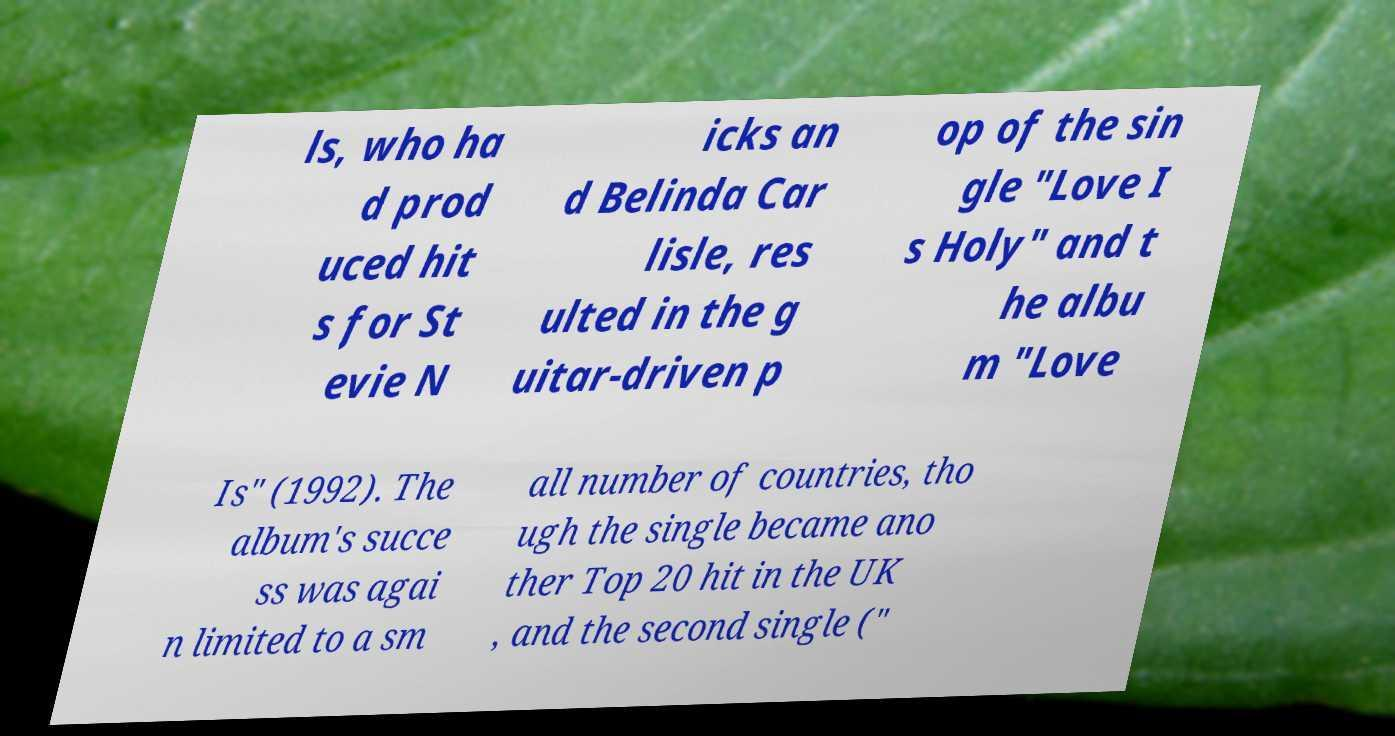What messages or text are displayed in this image? I need them in a readable, typed format. ls, who ha d prod uced hit s for St evie N icks an d Belinda Car lisle, res ulted in the g uitar-driven p op of the sin gle "Love I s Holy" and t he albu m "Love Is" (1992). The album's succe ss was agai n limited to a sm all number of countries, tho ugh the single became ano ther Top 20 hit in the UK , and the second single (" 